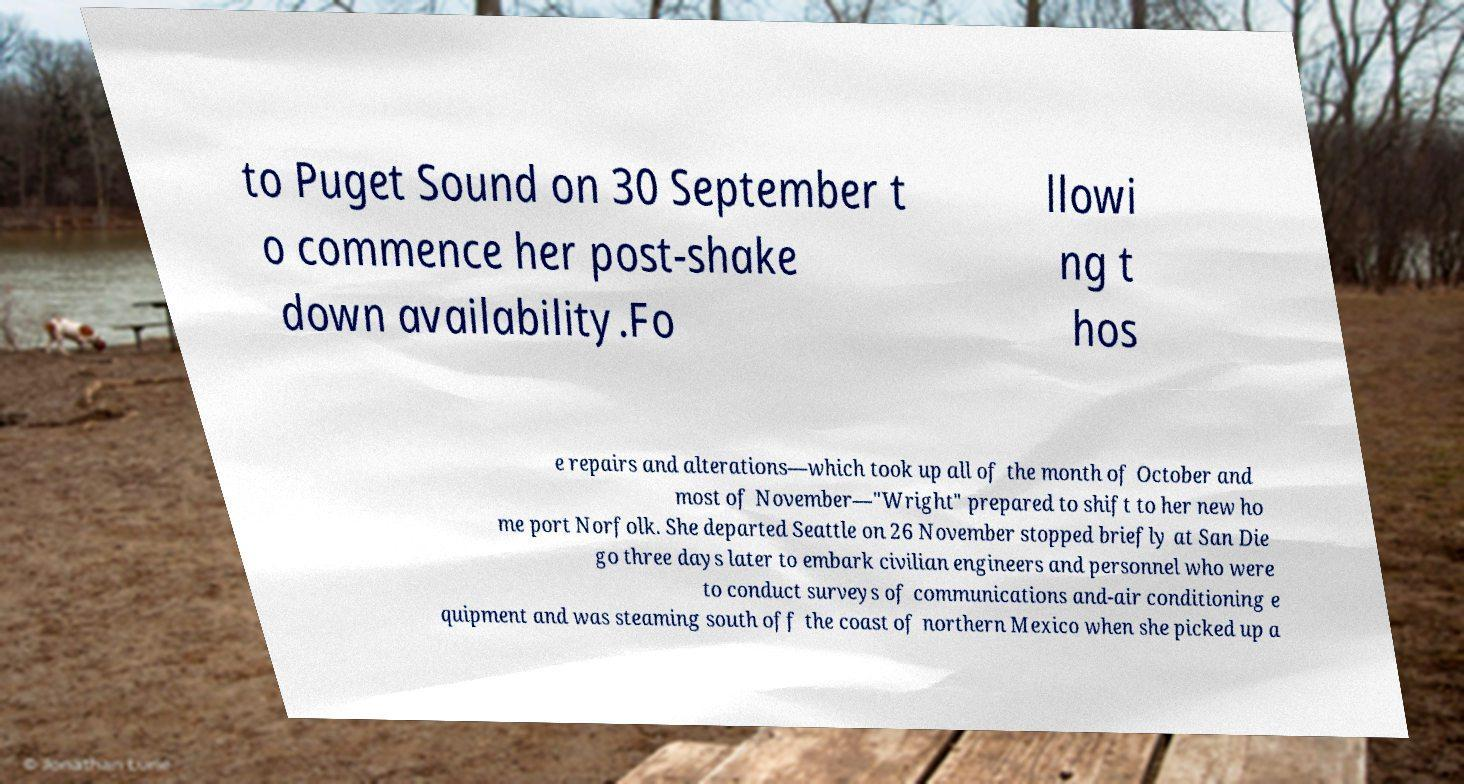For documentation purposes, I need the text within this image transcribed. Could you provide that? to Puget Sound on 30 September t o commence her post-shake down availability.Fo llowi ng t hos e repairs and alterations—which took up all of the month of October and most of November—"Wright" prepared to shift to her new ho me port Norfolk. She departed Seattle on 26 November stopped briefly at San Die go three days later to embark civilian engineers and personnel who were to conduct surveys of communications and-air conditioning e quipment and was steaming south off the coast of northern Mexico when she picked up a 